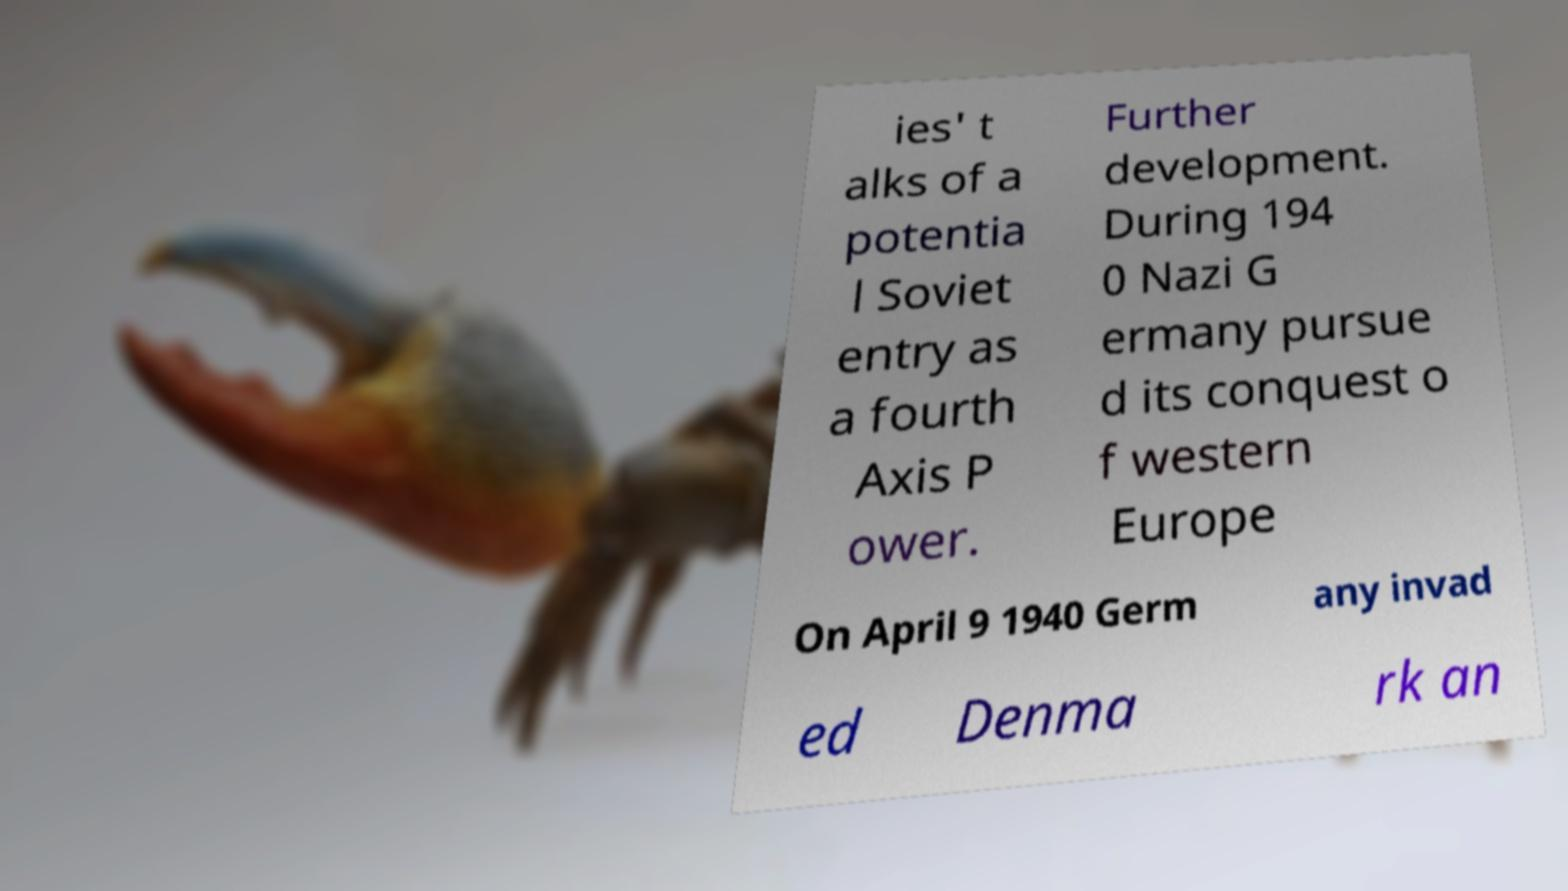Please read and relay the text visible in this image. What does it say? ies' t alks of a potentia l Soviet entry as a fourth Axis P ower. Further development. During 194 0 Nazi G ermany pursue d its conquest o f western Europe On April 9 1940 Germ any invad ed Denma rk an 